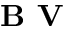Convert formula to latex. <formula><loc_0><loc_0><loc_500><loc_500>B V</formula> 